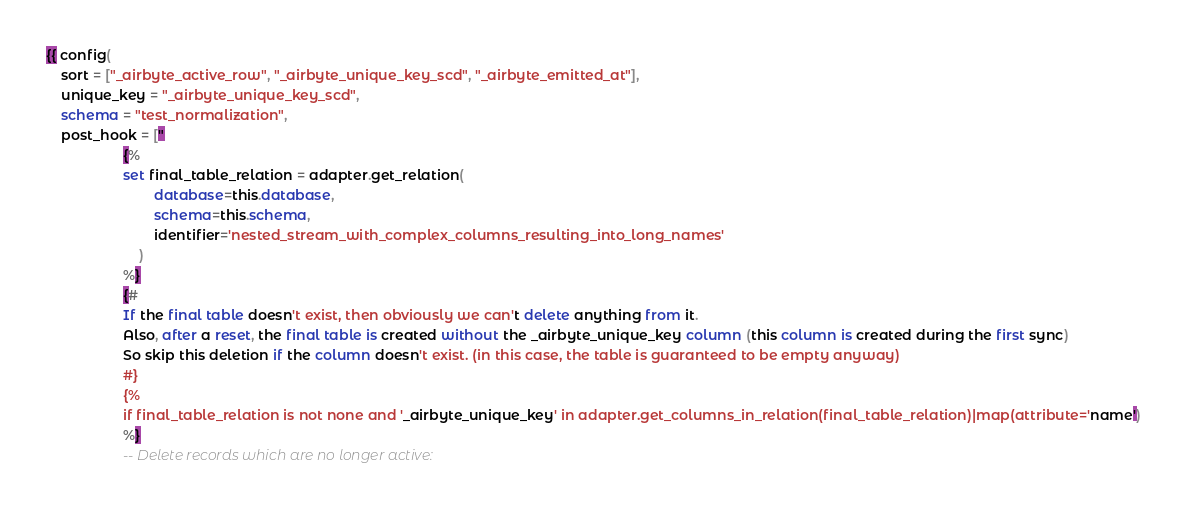Convert code to text. <code><loc_0><loc_0><loc_500><loc_500><_SQL_>{{ config(
    sort = ["_airbyte_active_row", "_airbyte_unique_key_scd", "_airbyte_emitted_at"],
    unique_key = "_airbyte_unique_key_scd",
    schema = "test_normalization",
    post_hook = ["
                    {%
                    set final_table_relation = adapter.get_relation(
                            database=this.database,
                            schema=this.schema,
                            identifier='nested_stream_with_complex_columns_resulting_into_long_names'
                        )
                    %}
                    {#
                    If the final table doesn't exist, then obviously we can't delete anything from it.
                    Also, after a reset, the final table is created without the _airbyte_unique_key column (this column is created during the first sync)
                    So skip this deletion if the column doesn't exist. (in this case, the table is guaranteed to be empty anyway)
                    #}
                    {%
                    if final_table_relation is not none and '_airbyte_unique_key' in adapter.get_columns_in_relation(final_table_relation)|map(attribute='name')
                    %}
                    -- Delete records which are no longer active:</code> 